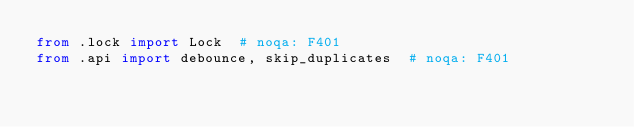Convert code to text. <code><loc_0><loc_0><loc_500><loc_500><_Python_>from .lock import Lock  # noqa: F401
from .api import debounce, skip_duplicates  # noqa: F401
</code> 